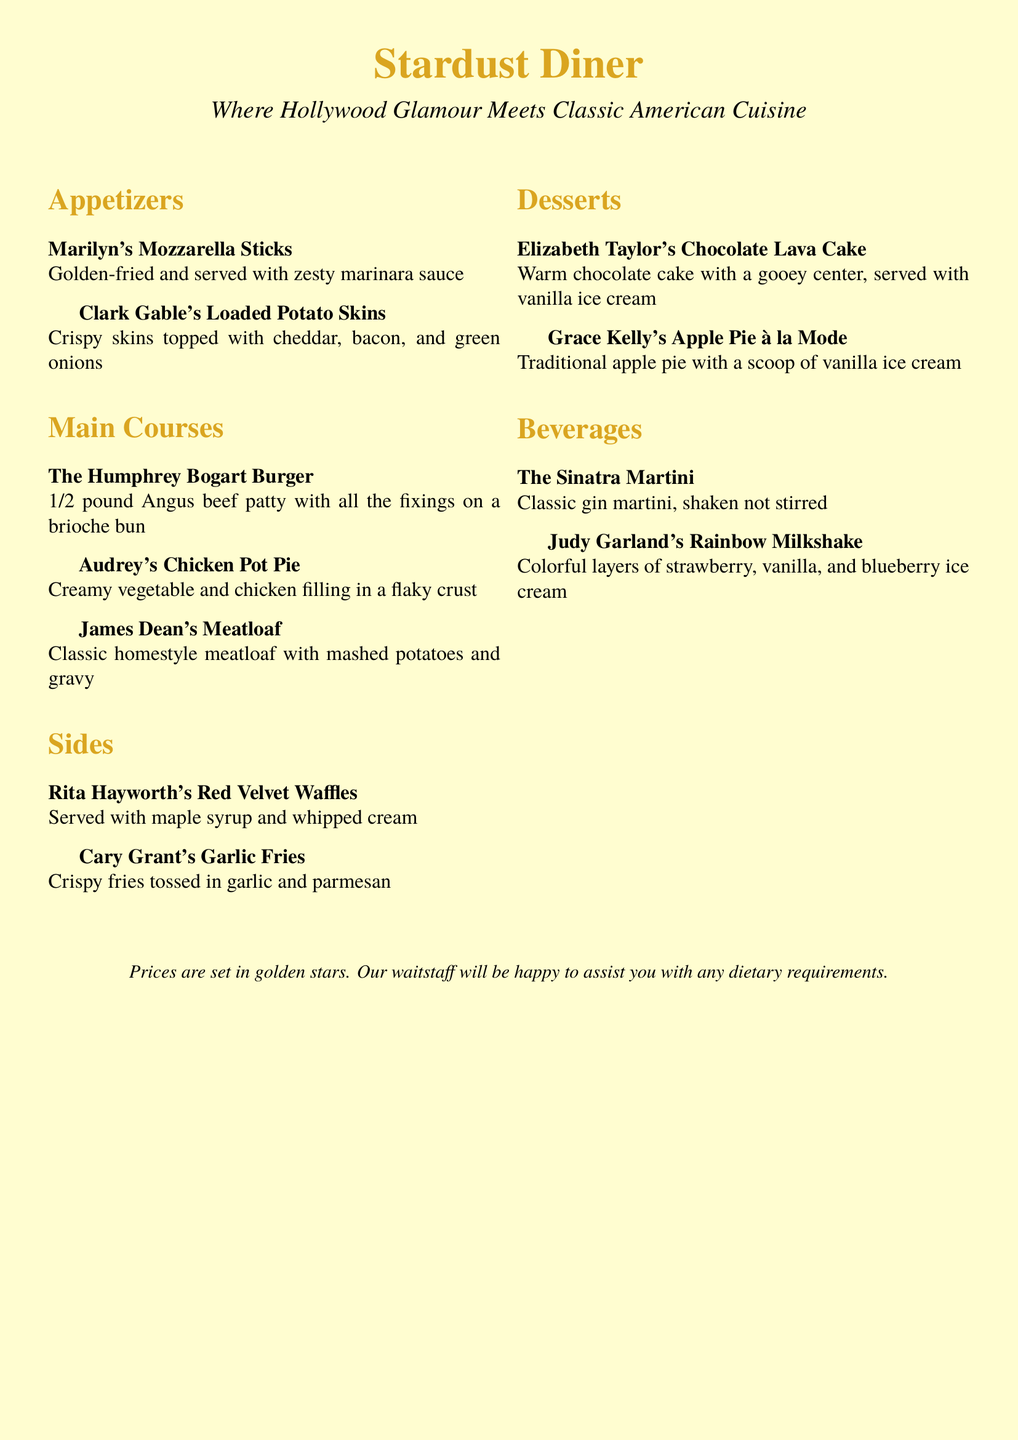What is the name of the diner? The name of the diner is prominently displayed at the top of the document.
Answer: Stardust Diner Who is the classic burger named after? The burger's name is specified in the main courses section of the menu.
Answer: Humphrey Bogart What dessert is served with vanilla ice cream? The menu describes specific desserts that include vanilla ice cream.
Answer: Grace Kelly's Apple Pie à la Mode What is the price format used in the menu? The footer of the document mentions how prices are presented.
Answer: Golden stars Which appetizer comes with marinara sauce? The appetizers section lists the foods and their accompaniments.
Answer: Marilyn's Mozzarella Sticks What type of drink is the Sinatra Martini? The beverages section categorizes the drinks and identifies their type.
Answer: Classic gin martini Which side dish includes parmesan? The sides section specifies toppings for various dishes.
Answer: Cary Grant's Garlic Fries What is Audrey's Chicken Pot Pie served in? The description of Audrey's Chicken Pot Pie provides details on its serving style.
Answer: Flaky crust 